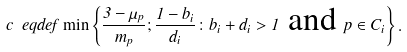<formula> <loc_0><loc_0><loc_500><loc_500>c \ e q d e f \min \left \{ \frac { 3 - \mu _ { p } } { m _ { p } } ; \frac { 1 - b _ { i } } { d _ { i } } \colon b _ { i } + d _ { i } > 1 \text { and } p \in C _ { i } \right \} .</formula> 